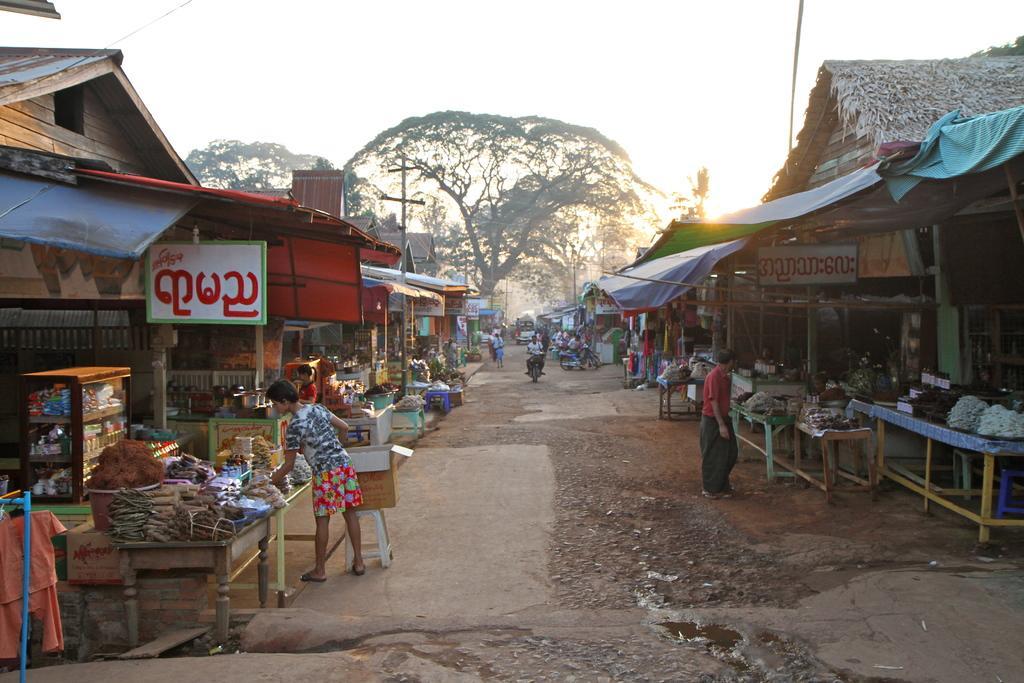Please provide a concise description of this image. This is a picture taken in the outdoors. It is sunny. There are group of people standing on the road and a person is riding a bike. There are shops, in shops there are tables on the table there are some items, cloth, boards, pole and rooftop. Behind the shops there are trees and sky. 